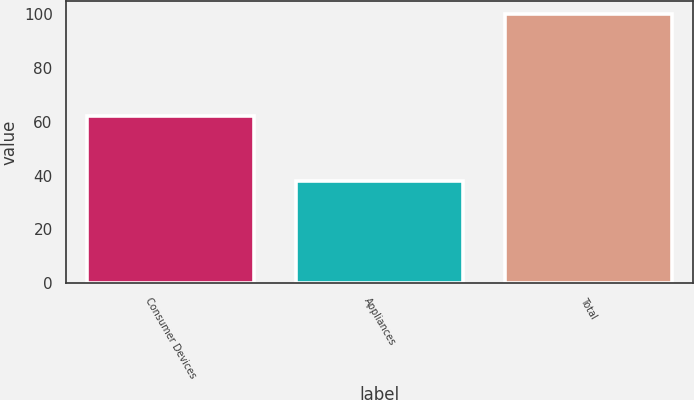<chart> <loc_0><loc_0><loc_500><loc_500><bar_chart><fcel>Consumer Devices<fcel>Appliances<fcel>Total<nl><fcel>62<fcel>38<fcel>100<nl></chart> 